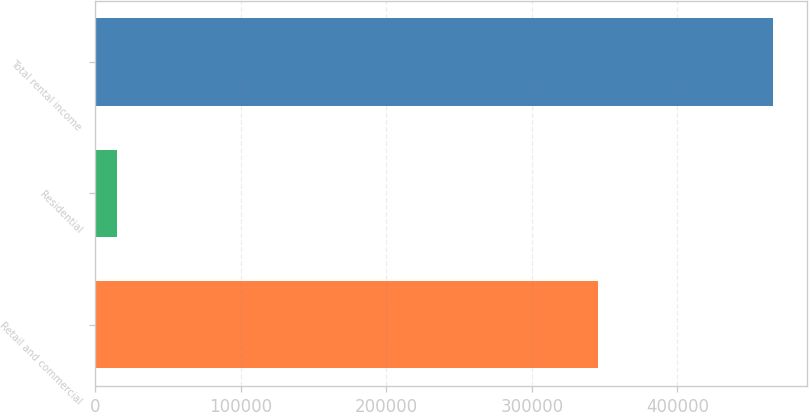Convert chart to OTSL. <chart><loc_0><loc_0><loc_500><loc_500><bar_chart><fcel>Retail and commercial<fcel>Residential<fcel>Total rental income<nl><fcel>345267<fcel>15312<fcel>465394<nl></chart> 